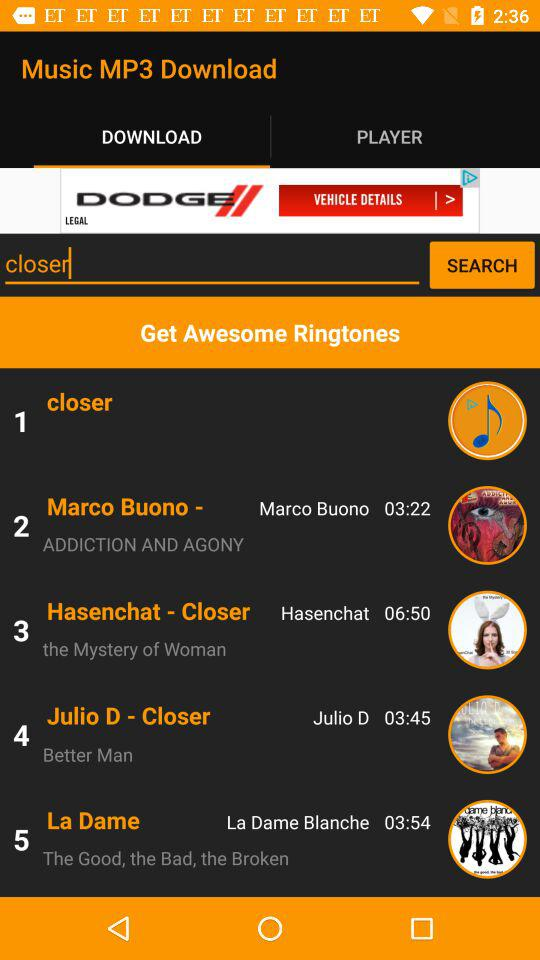Which tab am I on? You are on the "DOWNLOAD" tab. 